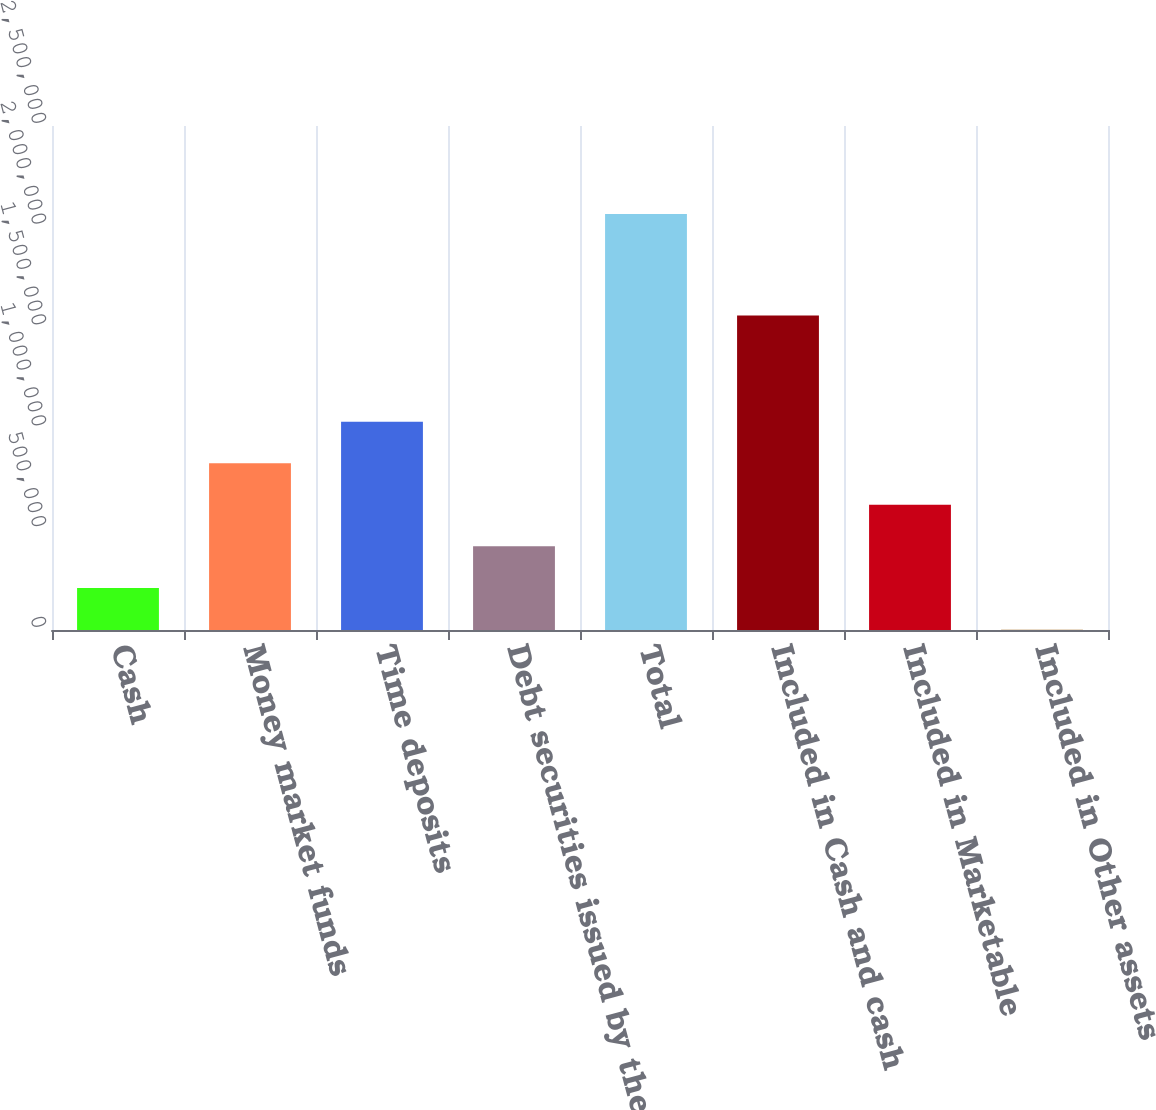Convert chart. <chart><loc_0><loc_0><loc_500><loc_500><bar_chart><fcel>Cash<fcel>Money market funds<fcel>Time deposits<fcel>Debt securities issued by the<fcel>Total<fcel>Included in Cash and cash<fcel>Included in Marketable<fcel>Included in Other assets<nl><fcel>208880<fcel>827139<fcel>1.03323e+06<fcel>414966<fcel>2.06366e+06<fcel>1.55963e+06<fcel>621053<fcel>2793<nl></chart> 